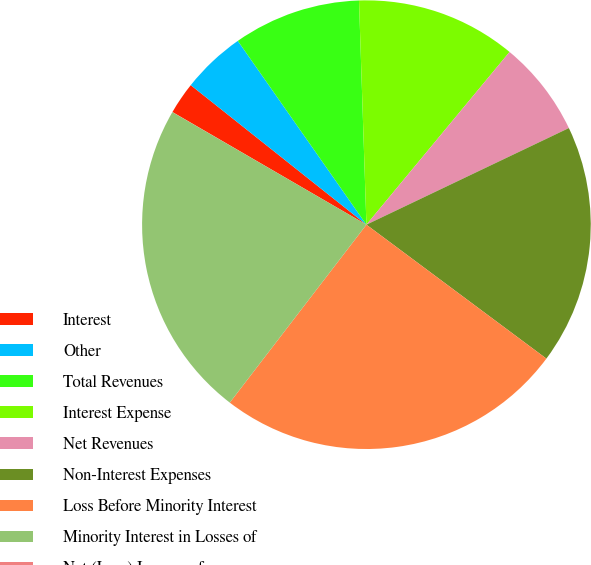Convert chart. <chart><loc_0><loc_0><loc_500><loc_500><pie_chart><fcel>Interest<fcel>Other<fcel>Total Revenues<fcel>Interest Expense<fcel>Net Revenues<fcel>Non-Interest Expenses<fcel>Loss Before Minority Interest<fcel>Minority Interest in Losses of<fcel>Net (Loss) Income of<nl><fcel>2.31%<fcel>4.6%<fcel>9.19%<fcel>11.54%<fcel>6.9%<fcel>17.27%<fcel>25.24%<fcel>22.94%<fcel>0.01%<nl></chart> 